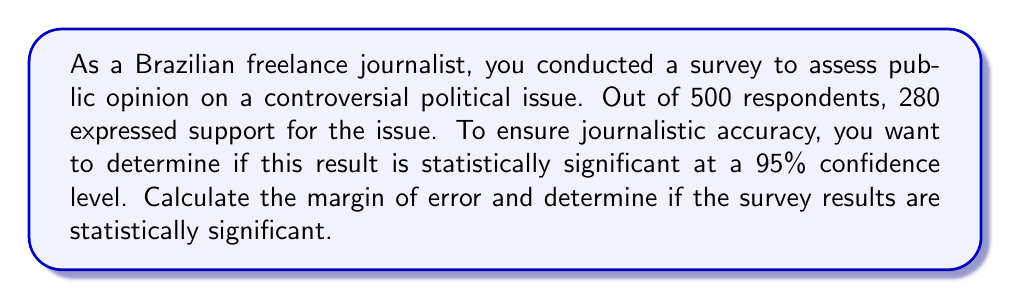Can you solve this math problem? To determine statistical significance, we'll follow these steps:

1. Calculate the sample proportion:
   $p = \frac{280}{500} = 0.56$ or 56%

2. Calculate the standard error:
   $SE = \sqrt{\frac{p(1-p)}{n}}$
   Where $n$ is the sample size (500)
   $SE = \sqrt{\frac{0.56(1-0.56)}{500}} = 0.0222$

3. Find the critical z-value for 95% confidence level:
   For 95% confidence, z = 1.96

4. Calculate the margin of error:
   $MoE = z \times SE = 1.96 \times 0.0222 = 0.0435$ or 4.35%

5. Determine statistical significance:
   The result is statistically significant if the proportion (56%) is more than the margin of error (4.35%) away from 50%.

   Lower bound: $0.56 - 0.0435 = 0.5165$
   Upper bound: $0.56 + 0.0435 = 0.6035$

   Since the lower bound (51.65%) is greater than 50%, the result is statistically significant at the 95% confidence level.

This means we can be 95% confident that the true population proportion lies between 51.65% and 60.35%, which does not include 50%. Therefore, the survey results are statistically significant and can be reported as showing a genuine preference in the population, avoiding sensationalist journalism by relying on statistical evidence.
Answer: Margin of Error: 4.35%; Statistically significant 